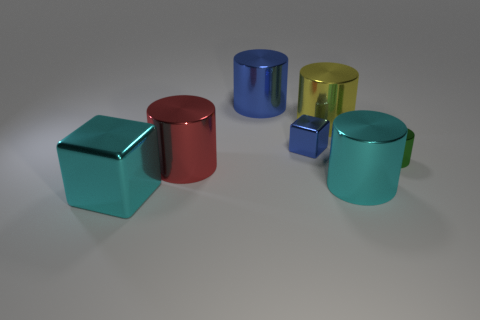There is a small block; does it have the same color as the object behind the yellow thing?
Offer a very short reply. Yes. The metal object that is the same color as the tiny shiny cube is what size?
Keep it short and to the point. Large. How many cylinders are the same color as the big metal cube?
Give a very brief answer. 1. There is a object that is the same color as the small cube; what is it made of?
Provide a succinct answer. Metal. Are there more things that are on the left side of the tiny metallic cylinder than cyan blocks?
Make the answer very short. Yes. Does the big yellow shiny object have the same shape as the green metal object?
Provide a short and direct response. Yes. How many big objects have the same material as the small green cylinder?
Your answer should be compact. 5. What size is the green metal thing that is the same shape as the large blue object?
Give a very brief answer. Small. Is the size of the cyan shiny cube the same as the green metal thing?
Your answer should be compact. No. The cyan metal object left of the tiny thing that is on the left side of the small metal thing that is right of the tiny blue thing is what shape?
Give a very brief answer. Cube. 